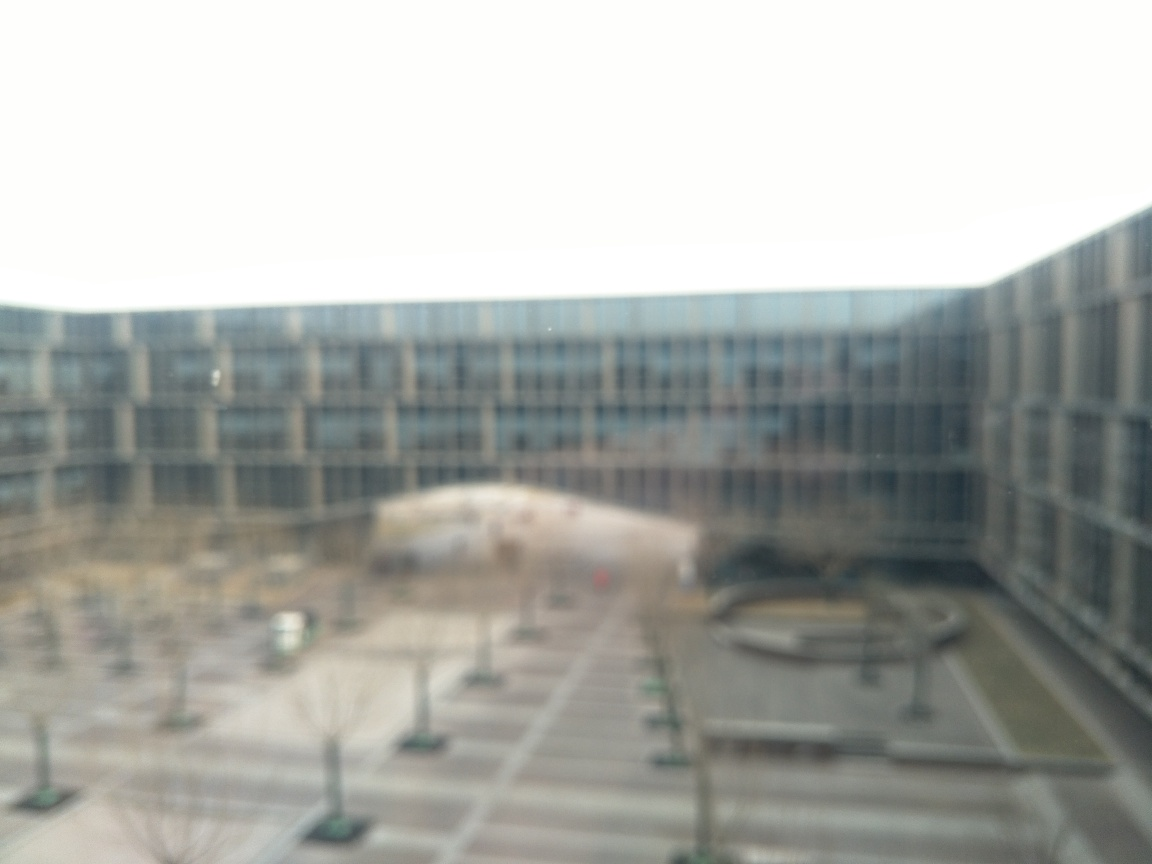Is the sharpness of the image noticeably low?
A. Yes
B. No
Answer with the option's letter from the given choices directly.
 A. 